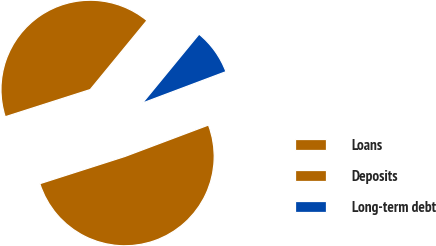Convert chart to OTSL. <chart><loc_0><loc_0><loc_500><loc_500><pie_chart><fcel>Loans<fcel>Deposits<fcel>Long-term debt<nl><fcel>40.87%<fcel>50.79%<fcel>8.33%<nl></chart> 